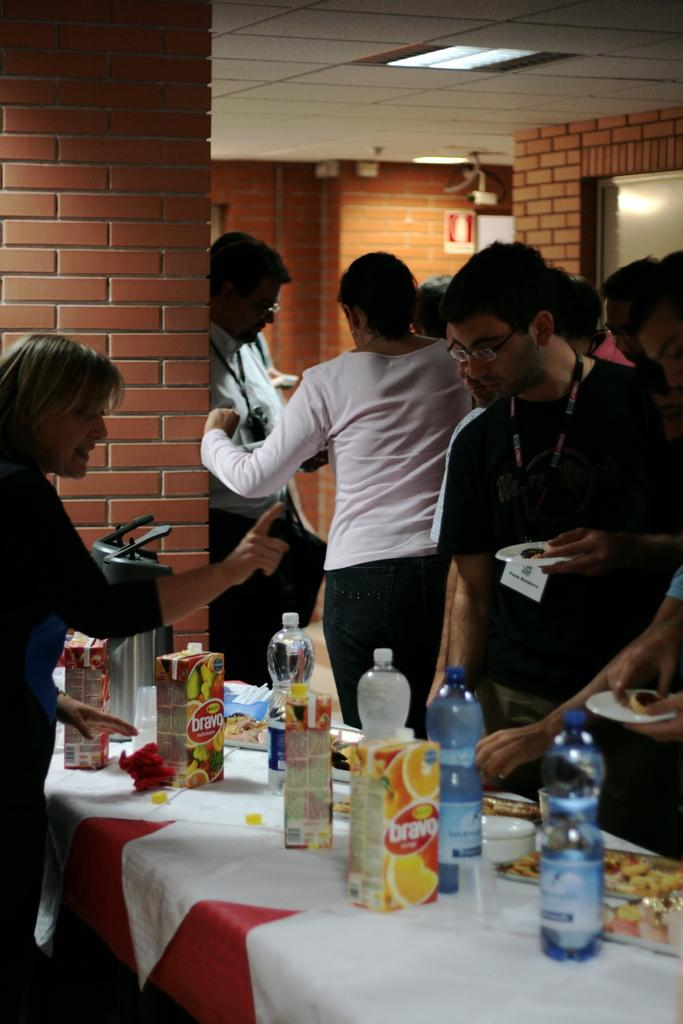What can be seen in the image involving people? There are persons standing in the image. What objects are on the table in the image? There are bottles on a table in the image. What is located in the background of the image? There is a board and a wall in the background of the image. What is the source of light in the image? There is a light visible at the top of the image. How many apples are being held in the mouths of the persons in the image? There are no apples or mouths visible in the image; the persons are standing and there are bottles on a table. 